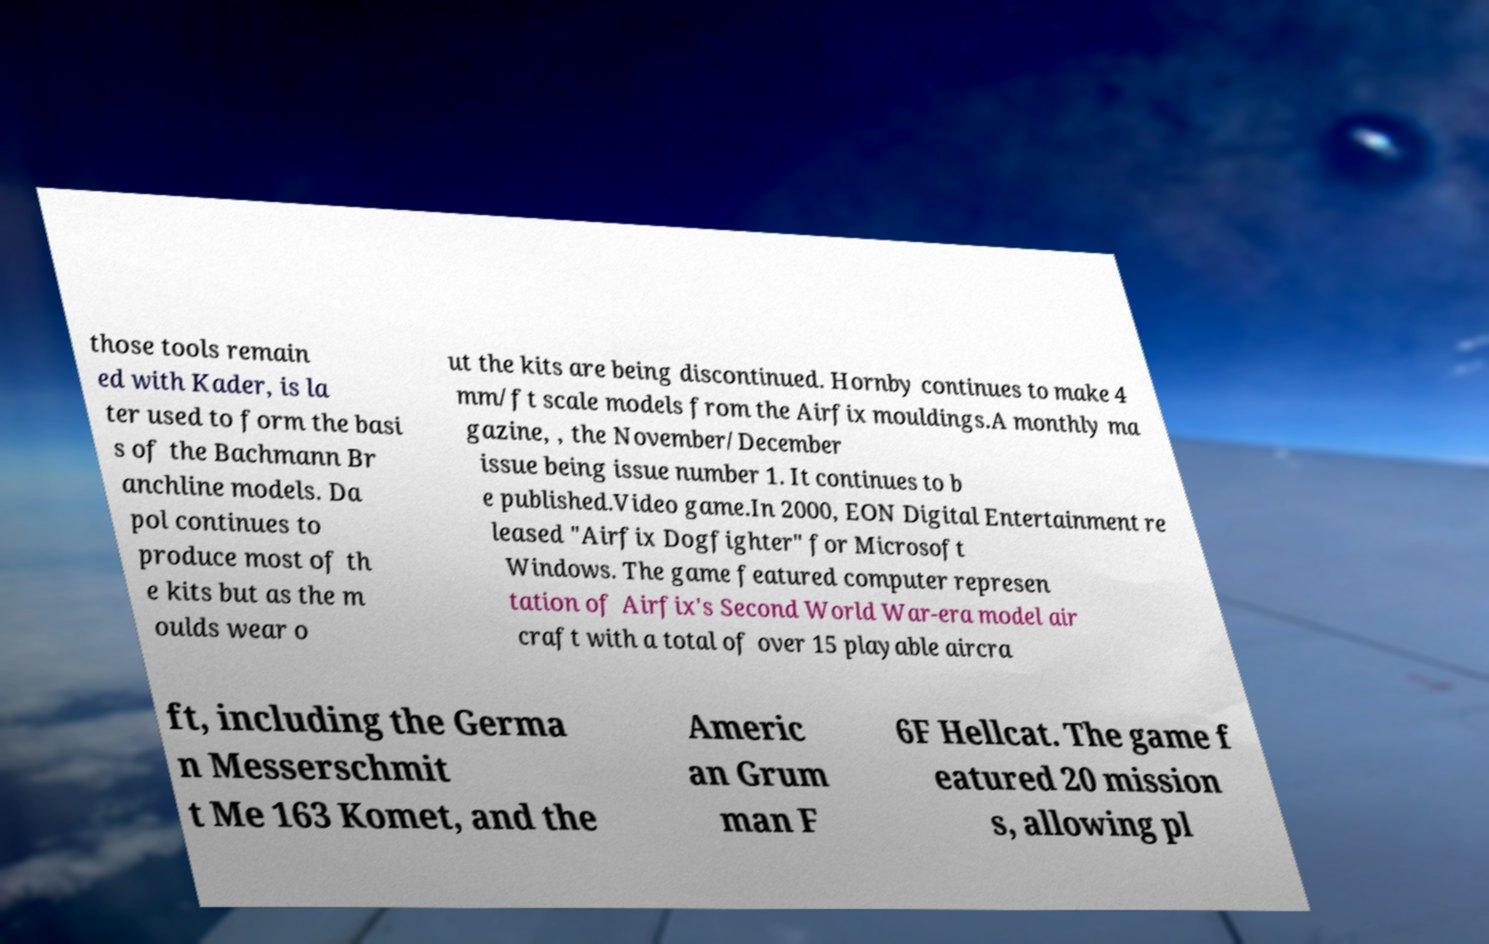What messages or text are displayed in this image? I need them in a readable, typed format. those tools remain ed with Kader, is la ter used to form the basi s of the Bachmann Br anchline models. Da pol continues to produce most of th e kits but as the m oulds wear o ut the kits are being discontinued. Hornby continues to make 4 mm/ft scale models from the Airfix mouldings.A monthly ma gazine, , the November/December issue being issue number 1. It continues to b e published.Video game.In 2000, EON Digital Entertainment re leased "Airfix Dogfighter" for Microsoft Windows. The game featured computer represen tation of Airfix's Second World War-era model air craft with a total of over 15 playable aircra ft, including the Germa n Messerschmit t Me 163 Komet, and the Americ an Grum man F 6F Hellcat. The game f eatured 20 mission s, allowing pl 